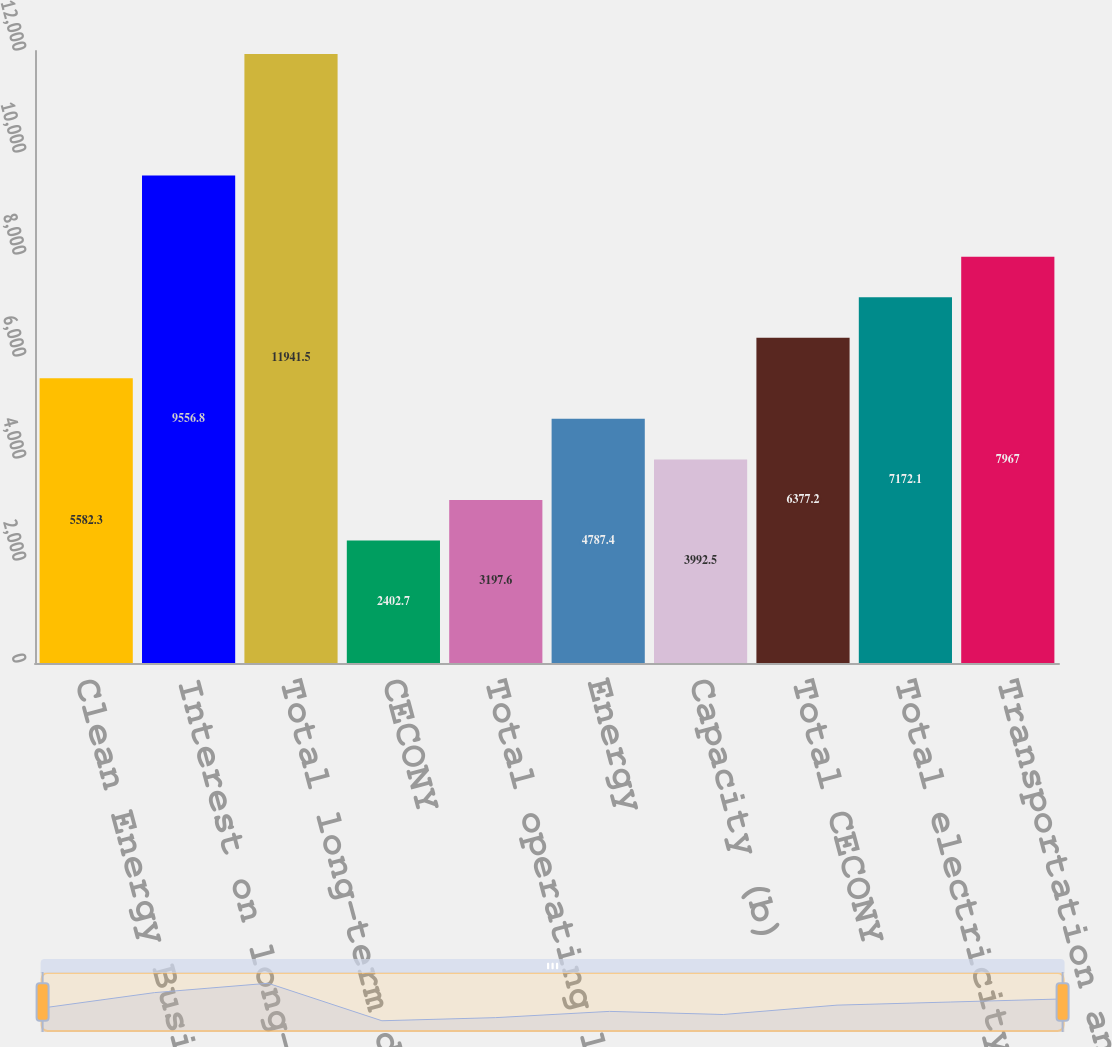<chart> <loc_0><loc_0><loc_500><loc_500><bar_chart><fcel>Clean Energy Businesses<fcel>Interest on long-term debt (a)<fcel>Total long-term debt including<fcel>CECONY<fcel>Total operating leases<fcel>Energy<fcel>Capacity (b)<fcel>Total CECONY<fcel>Total electricity and power<fcel>Transportation and storage<nl><fcel>5582.3<fcel>9556.8<fcel>11941.5<fcel>2402.7<fcel>3197.6<fcel>4787.4<fcel>3992.5<fcel>6377.2<fcel>7172.1<fcel>7967<nl></chart> 